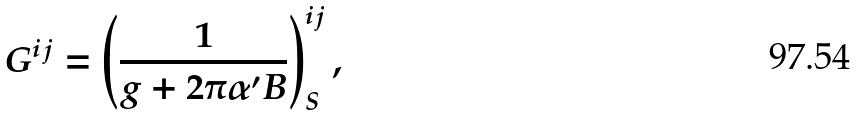<formula> <loc_0><loc_0><loc_500><loc_500>G ^ { i j } = \left ( \frac { 1 } { g + 2 \pi \alpha ^ { \prime } B } \right ) _ { S } ^ { i j } ,</formula> 